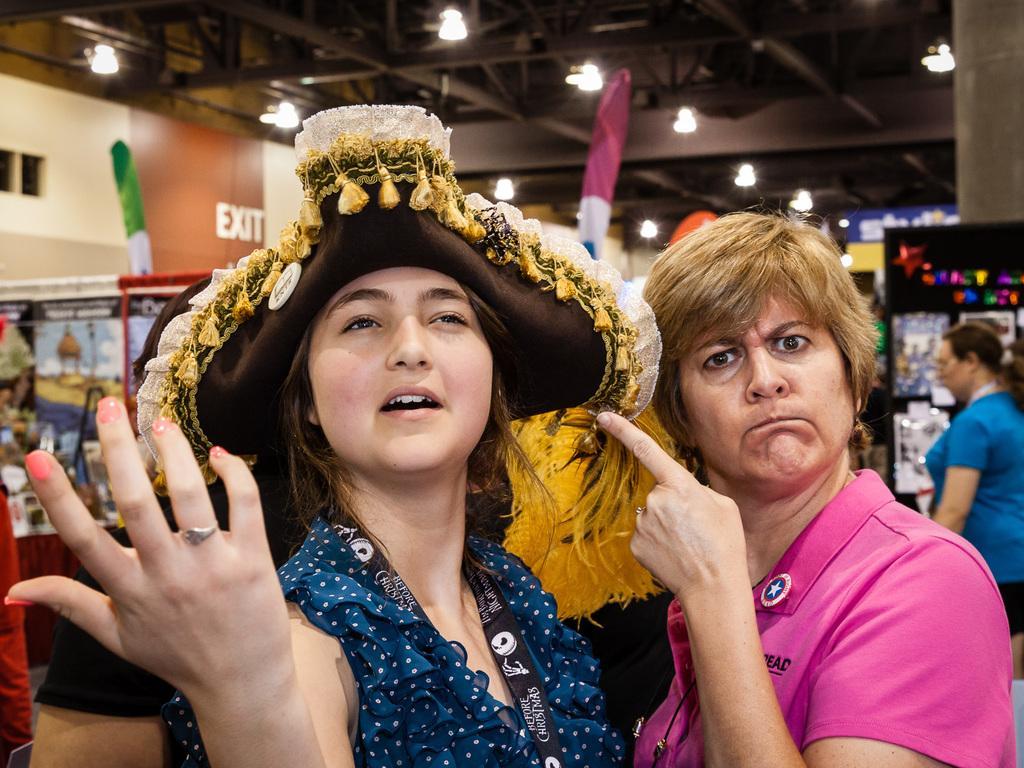Could you give a brief overview of what you see in this image? In this picture I can see the two women in the middle, on the right side there is another woman wearing the blue color t-shirt, at the top there are lights, it looks like a store. 